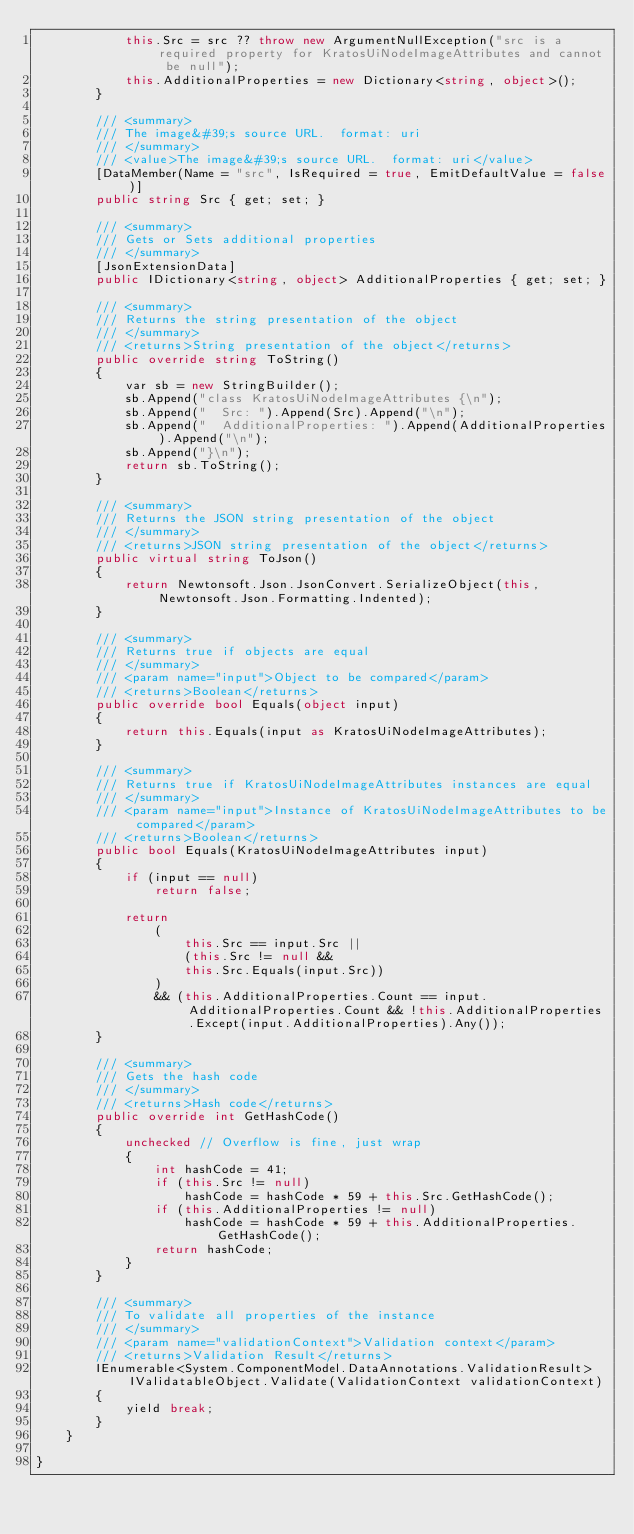<code> <loc_0><loc_0><loc_500><loc_500><_C#_>            this.Src = src ?? throw new ArgumentNullException("src is a required property for KratosUiNodeImageAttributes and cannot be null");
            this.AdditionalProperties = new Dictionary<string, object>();
        }

        /// <summary>
        /// The image&#39;s source URL.  format: uri
        /// </summary>
        /// <value>The image&#39;s source URL.  format: uri</value>
        [DataMember(Name = "src", IsRequired = true, EmitDefaultValue = false)]
        public string Src { get; set; }

        /// <summary>
        /// Gets or Sets additional properties
        /// </summary>
        [JsonExtensionData]
        public IDictionary<string, object> AdditionalProperties { get; set; }

        /// <summary>
        /// Returns the string presentation of the object
        /// </summary>
        /// <returns>String presentation of the object</returns>
        public override string ToString()
        {
            var sb = new StringBuilder();
            sb.Append("class KratosUiNodeImageAttributes {\n");
            sb.Append("  Src: ").Append(Src).Append("\n");
            sb.Append("  AdditionalProperties: ").Append(AdditionalProperties).Append("\n");
            sb.Append("}\n");
            return sb.ToString();
        }

        /// <summary>
        /// Returns the JSON string presentation of the object
        /// </summary>
        /// <returns>JSON string presentation of the object</returns>
        public virtual string ToJson()
        {
            return Newtonsoft.Json.JsonConvert.SerializeObject(this, Newtonsoft.Json.Formatting.Indented);
        }

        /// <summary>
        /// Returns true if objects are equal
        /// </summary>
        /// <param name="input">Object to be compared</param>
        /// <returns>Boolean</returns>
        public override bool Equals(object input)
        {
            return this.Equals(input as KratosUiNodeImageAttributes);
        }

        /// <summary>
        /// Returns true if KratosUiNodeImageAttributes instances are equal
        /// </summary>
        /// <param name="input">Instance of KratosUiNodeImageAttributes to be compared</param>
        /// <returns>Boolean</returns>
        public bool Equals(KratosUiNodeImageAttributes input)
        {
            if (input == null)
                return false;

            return 
                (
                    this.Src == input.Src ||
                    (this.Src != null &&
                    this.Src.Equals(input.Src))
                )
                && (this.AdditionalProperties.Count == input.AdditionalProperties.Count && !this.AdditionalProperties.Except(input.AdditionalProperties).Any());
        }

        /// <summary>
        /// Gets the hash code
        /// </summary>
        /// <returns>Hash code</returns>
        public override int GetHashCode()
        {
            unchecked // Overflow is fine, just wrap
            {
                int hashCode = 41;
                if (this.Src != null)
                    hashCode = hashCode * 59 + this.Src.GetHashCode();
                if (this.AdditionalProperties != null)
                    hashCode = hashCode * 59 + this.AdditionalProperties.GetHashCode();
                return hashCode;
            }
        }

        /// <summary>
        /// To validate all properties of the instance
        /// </summary>
        /// <param name="validationContext">Validation context</param>
        /// <returns>Validation Result</returns>
        IEnumerable<System.ComponentModel.DataAnnotations.ValidationResult> IValidatableObject.Validate(ValidationContext validationContext)
        {
            yield break;
        }
    }

}
</code> 